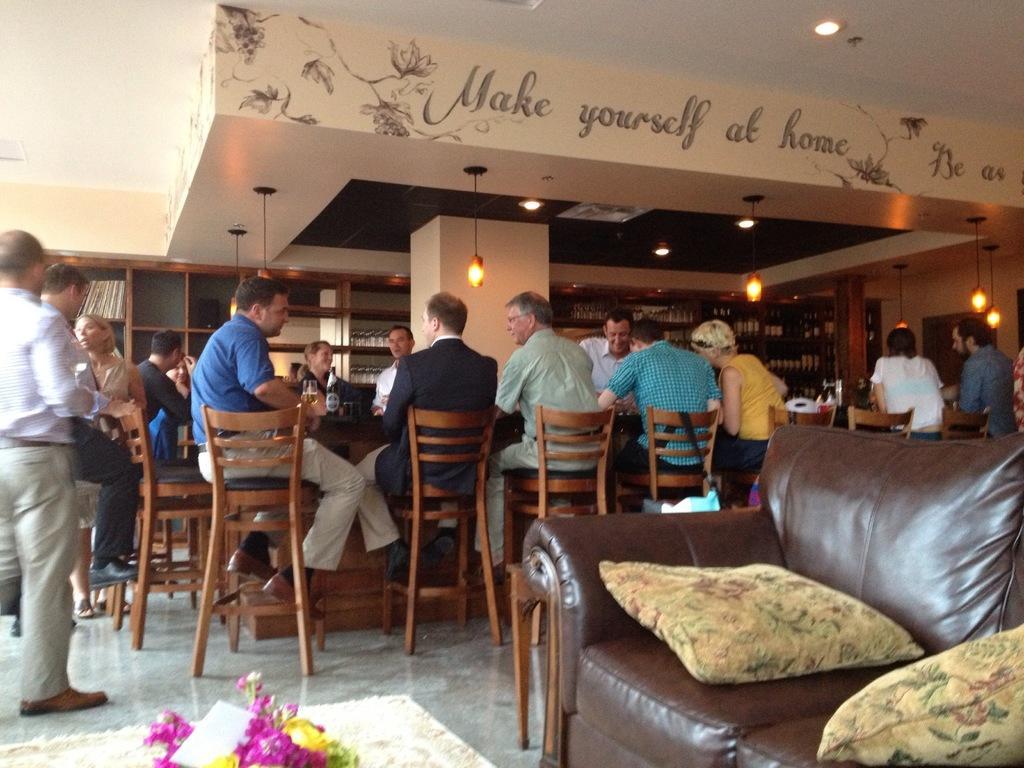Describe this image in one or two sentences. There are group of persons sitting on the chairs at the left side of the image a blue color man holding a glass which consists of alcohol,At the bottom right of the image there is a couch on which there are two pillows and at the left bottom of the image there is a flower bouquet and at the top of the image there is a beam on which it is written as make yourself at home. 